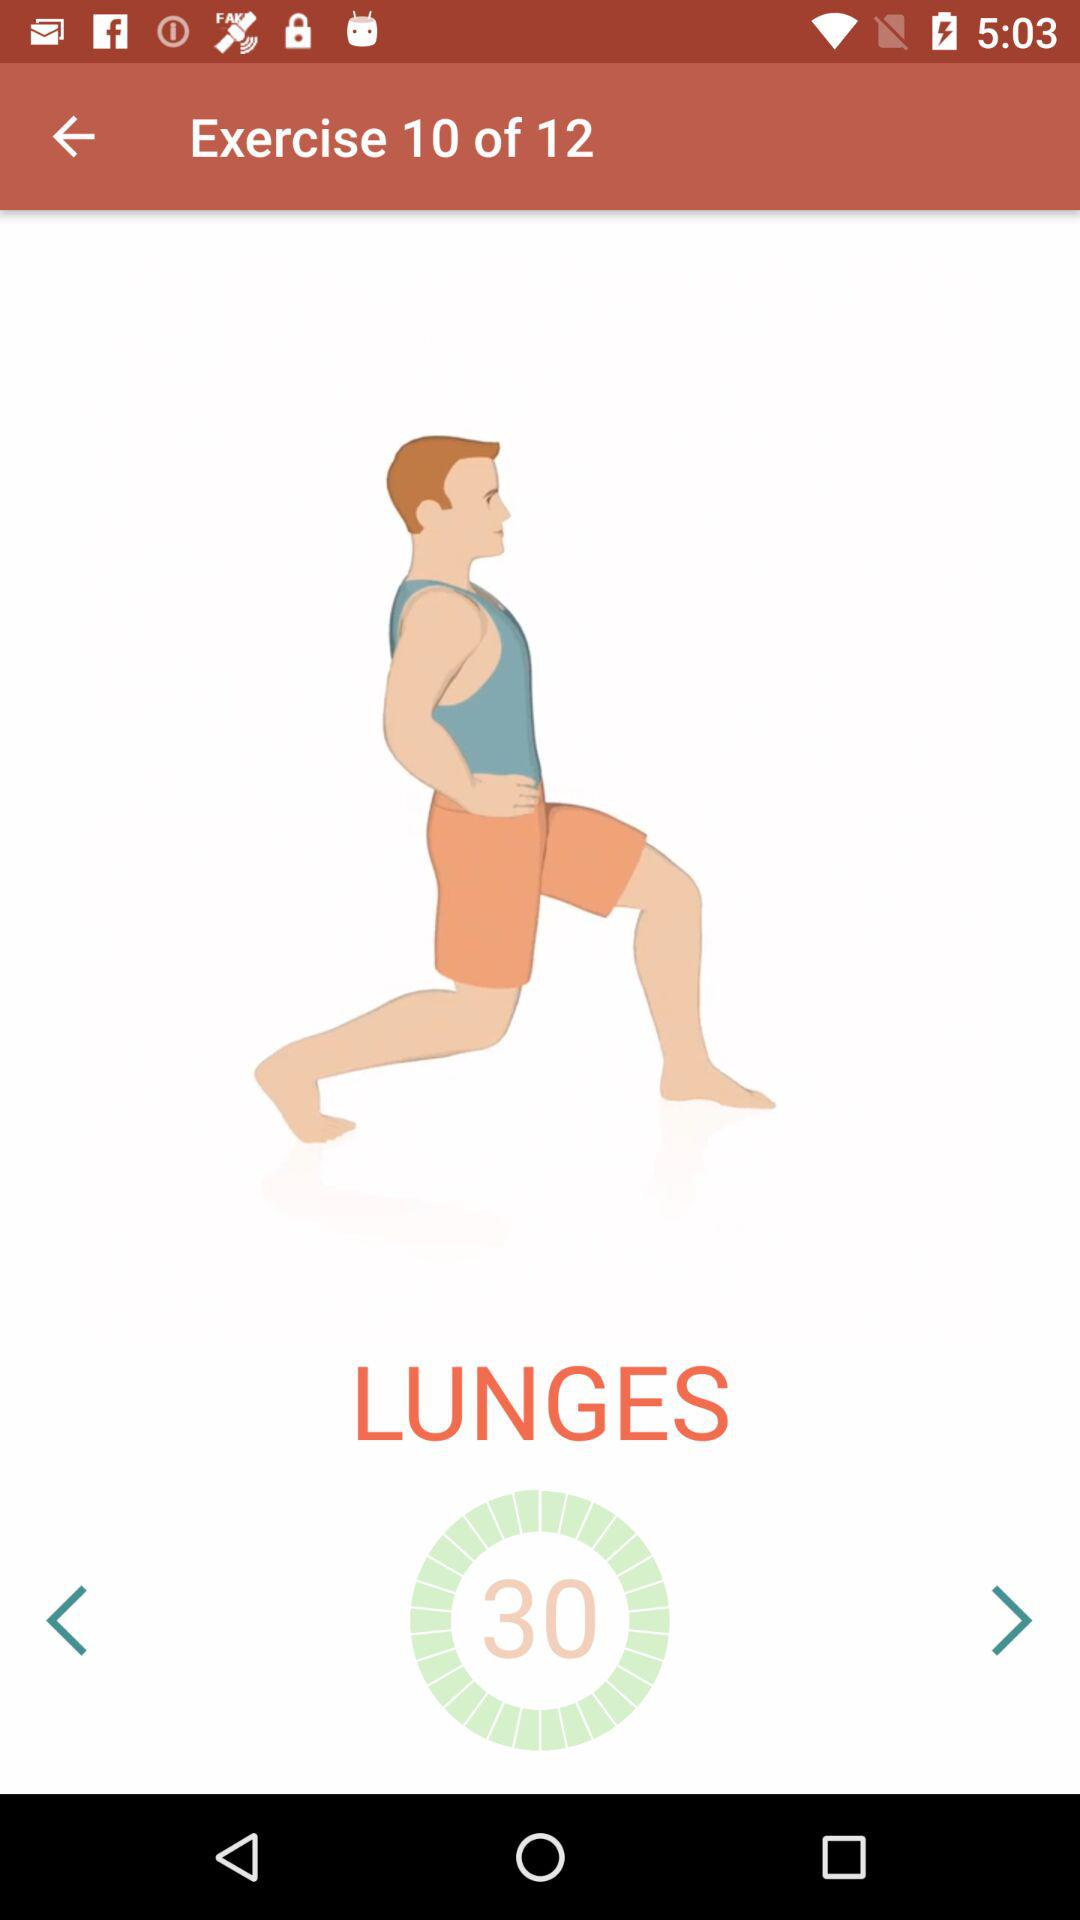How many exercises are there? There are 12 exercises. 